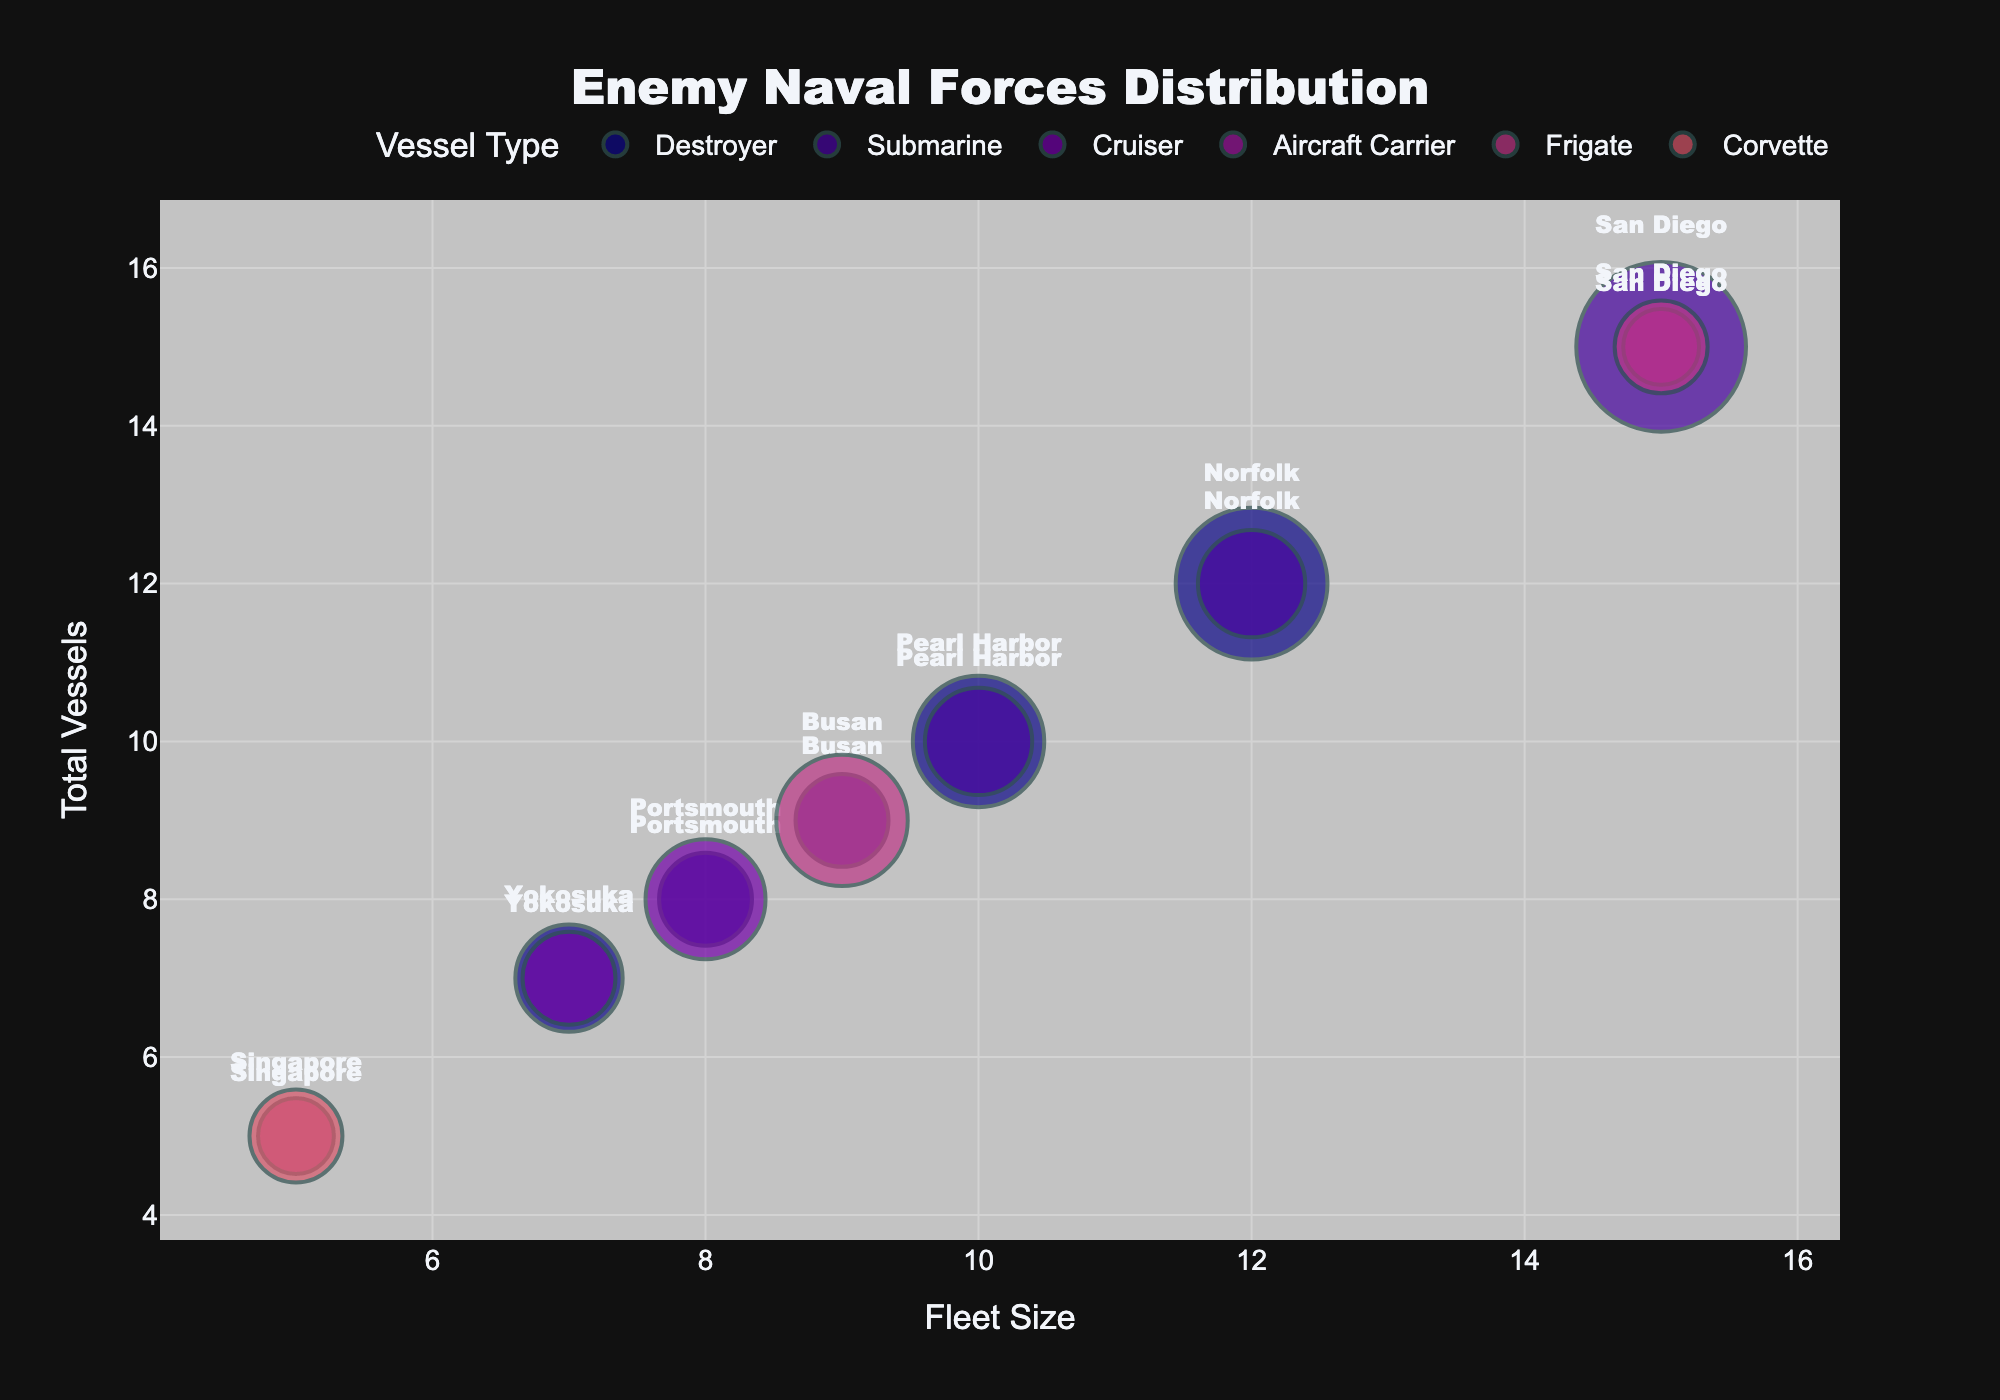What is the title of the figure? The title is usually at the top of the chart. In this case, it reads "Enemy Naval Forces Distribution."
Answer: Enemy Naval Forces Distribution How many different types of vessels are represented in the figure? Look at the legend to identify the distinct categories of vessel types based on color coding. There are six types: Destroyer, Submarine, Cruiser, Aircraft Carrier, Frigate, and Corvette.
Answer: Six Which port has the largest total number of vessels? Examine the y-axis which represents the total number of vessels and look for the port corresponding to the highest point on this axis. San Diego has the highest total number of vessels at 15.
Answer: San Diego How many vessels of the type "Destroyer" are stationed in Norfolk? Identify the bubble color corresponding to "Destroyer" and locate the bubbles labeled "Norfolk." The bubble size indicates the number of vessels, which is 8 for Norfolk.
Answer: Eight What is the relationship between fleet size and total number of vessels in San Diego? Find the point labeled San Diego and observe its coordinates. Fleet size is on the x-axis, total vessels on the y-axis. San Diego has a fleet size of 15 and a total of 15 vessels, indicating a direct relationship.
Answer: Direct relationship (15 fleet size, 15 total vessels) Which port has the smallest total fleet size and what is it? Look for the point with the smallest x-coordinate value under the ‘Fleet Size’ axis. Singapore has the smallest total fleet size, which is 5.
Answer: Singapore (5) What is the total number of destroyers across all ports? Add up the number of vessels categorized as Destroyers across all ports. Norfolk: 8, Portsmouth: 3, Pearl Harbor: 6, Yokosuka: 4. The total is 8 + 3 + 6 + 4 = 21.
Answer: 21 How does the fleet size of Norfolk compare to that of Yokosuka? Compare the x-axis values for Norfolk and Yokosuka. Norfolk has a fleet size of 12 while Yokosuka has a fleet size of 7, so Norfolk's fleet is larger.
Answer: Norfolk's fleet is larger Which type of vessel has the largest number stationed in a single port, and what is that number? Look for the largest bubble and identify its corresponding vessel type and number. "Submarine" in San Diego has the largest number, which is 10.
Answer: Submarine (10 in San Diego) What are the total vessels in Portsmouth, and which vessels make up this total? Check the data for Portsmouth. The total is the sum of all vessel types there: 5 Cruisers + 3 Destroyers = 8.
Answer: 8 (5 Cruisers + 3 Destroyers) 